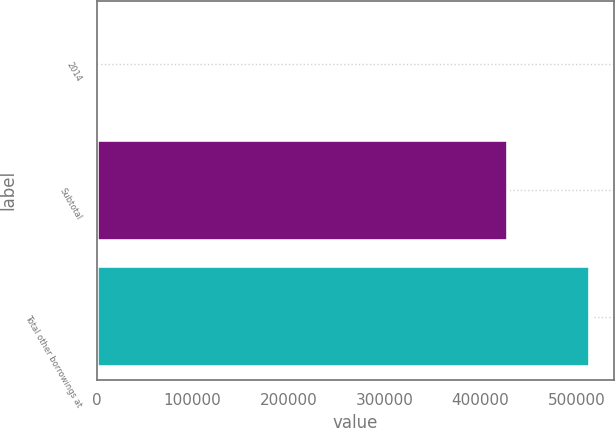Convert chart to OTSL. <chart><loc_0><loc_0><loc_500><loc_500><bar_chart><fcel>2014<fcel>Subtotal<fcel>Total other borrowings at<nl><fcel>346<fcel>428182<fcel>513946<nl></chart> 